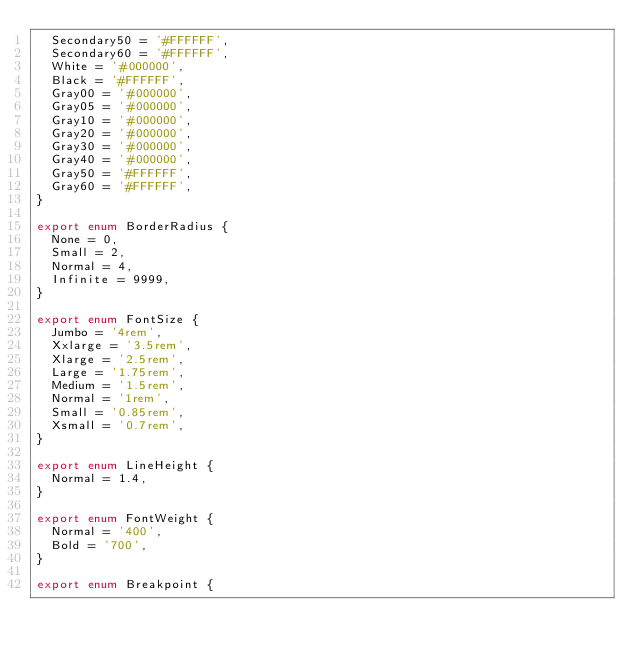Convert code to text. <code><loc_0><loc_0><loc_500><loc_500><_TypeScript_>  Secondary50 = '#FFFFFF',
  Secondary60 = '#FFFFFF',
  White = '#000000',
  Black = '#FFFFFF',
  Gray00 = '#000000',
  Gray05 = '#000000',
  Gray10 = '#000000',
  Gray20 = '#000000',
  Gray30 = '#000000',
  Gray40 = '#000000',
  Gray50 = '#FFFFFF',
  Gray60 = '#FFFFFF',
}

export enum BorderRadius {
  None = 0,
  Small = 2,
  Normal = 4,
  Infinite = 9999,
}

export enum FontSize {
  Jumbo = '4rem',
  Xxlarge = '3.5rem',
  Xlarge = '2.5rem',
  Large = '1.75rem',
  Medium = '1.5rem',
  Normal = '1rem',
  Small = '0.85rem',
  Xsmall = '0.7rem',
}

export enum LineHeight {
  Normal = 1.4,
}

export enum FontWeight {
  Normal = '400',
  Bold = '700',
}

export enum Breakpoint {</code> 